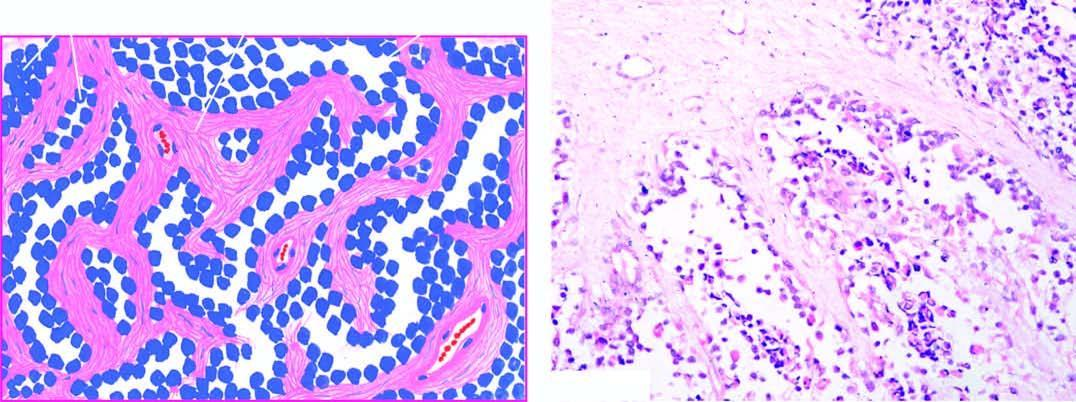re a few multinucleate tumour giant cells also present?
Answer the question using a single word or phrase. Yes 